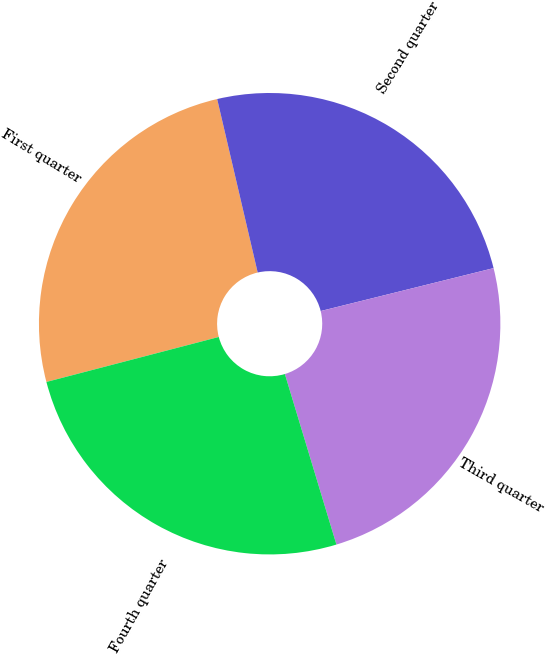<chart> <loc_0><loc_0><loc_500><loc_500><pie_chart><fcel>First quarter<fcel>Second quarter<fcel>Third quarter<fcel>Fourth quarter<nl><fcel>25.41%<fcel>24.78%<fcel>24.2%<fcel>25.61%<nl></chart> 